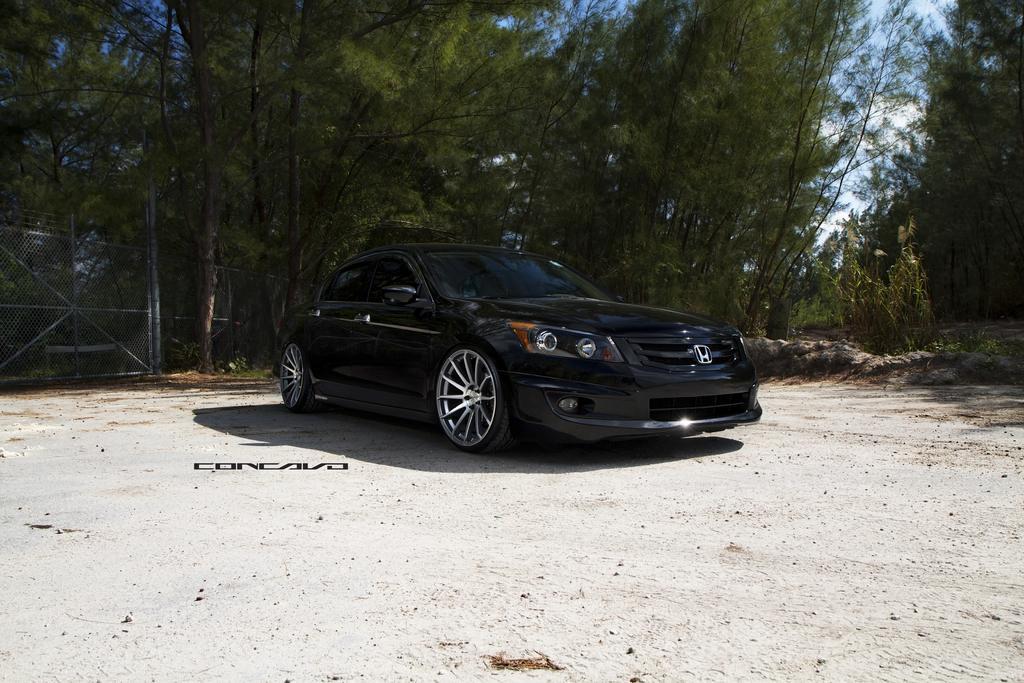In one or two sentences, can you explain what this image depicts? Here we can see a black color car on the ground. In the background we can see fence,poles,trees and clouds in the sky. 